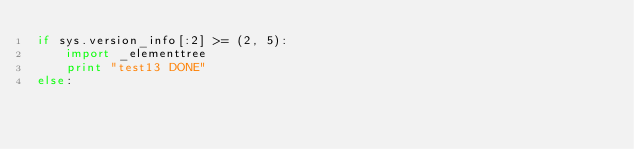Convert code to text. <code><loc_0><loc_0><loc_500><loc_500><_Python_>if sys.version_info[:2] >= (2, 5):
    import _elementtree
    print "test13 DONE"
else:</code> 